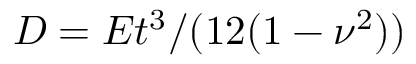Convert formula to latex. <formula><loc_0><loc_0><loc_500><loc_500>D = E t ^ { 3 } / ( 1 2 ( 1 - \nu ^ { 2 } ) )</formula> 